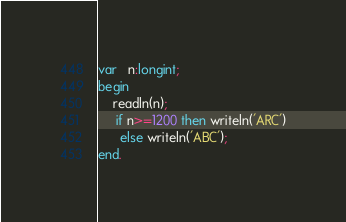Convert code to text. <code><loc_0><loc_0><loc_500><loc_500><_Pascal_>var   n:longint;
begin
    readln(n);
     if n>=1200 then writeln('ARC')
      else writeln('ABC');
end.</code> 